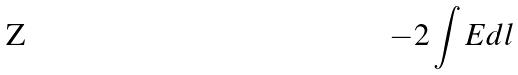<formula> <loc_0><loc_0><loc_500><loc_500>- 2 \int E d l</formula> 